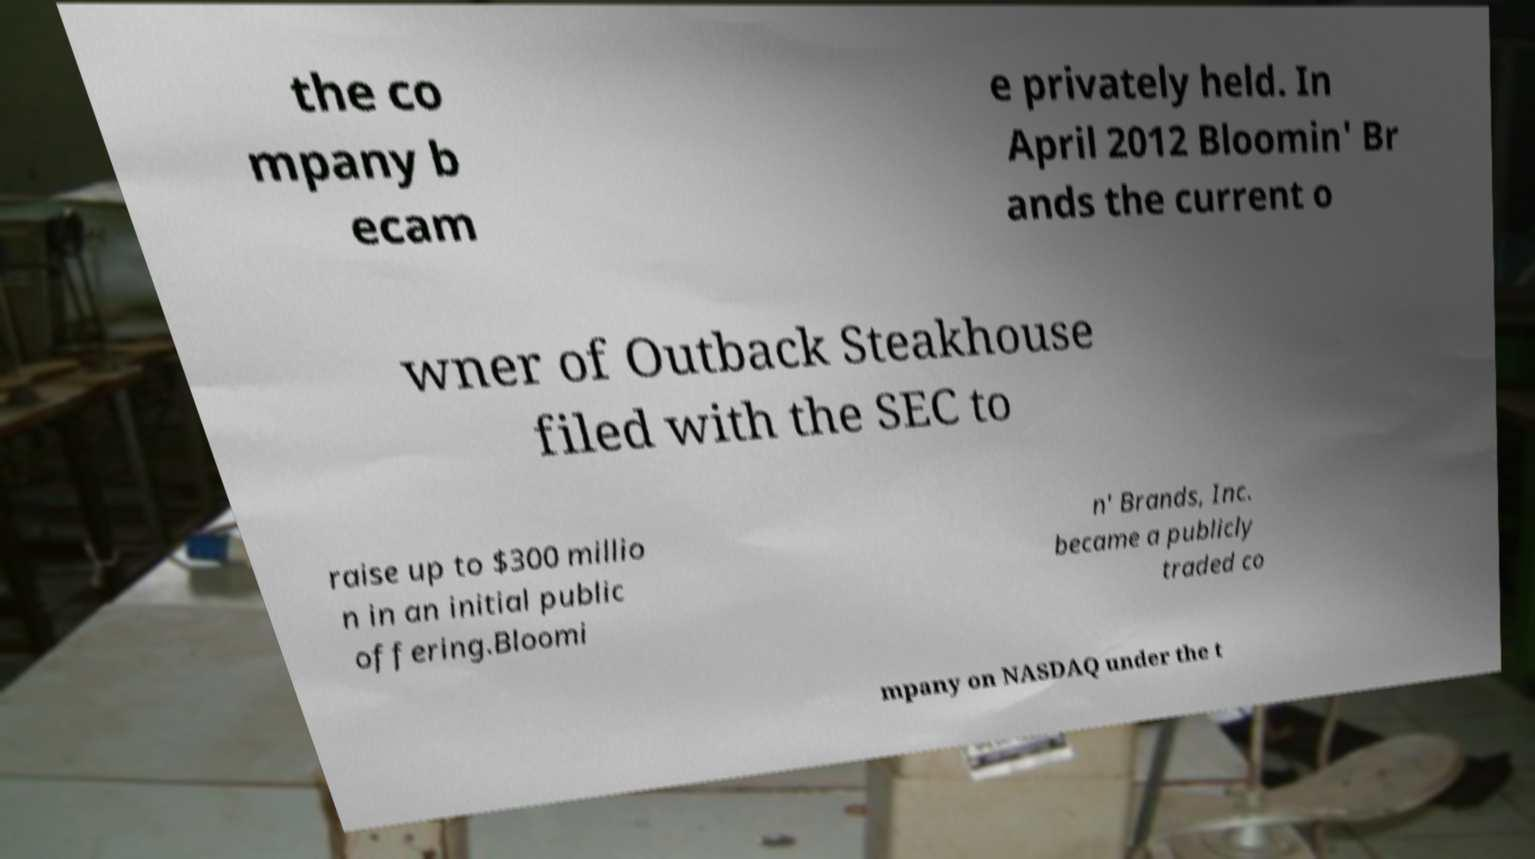I need the written content from this picture converted into text. Can you do that? the co mpany b ecam e privately held. In April 2012 Bloomin' Br ands the current o wner of Outback Steakhouse filed with the SEC to raise up to $300 millio n in an initial public offering.Bloomi n' Brands, Inc. became a publicly traded co mpany on NASDAQ under the t 